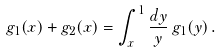<formula> <loc_0><loc_0><loc_500><loc_500>g _ { 1 } ( x ) + g _ { 2 } ( x ) = \int _ { x } ^ { 1 } \frac { d y } { y } \, g _ { 1 } ( y ) \, .</formula> 